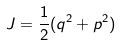<formula> <loc_0><loc_0><loc_500><loc_500>J = \frac { 1 } { 2 } ( q ^ { 2 } + p ^ { 2 } )</formula> 